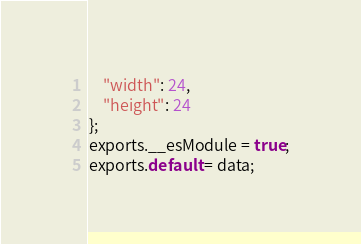Convert code to text. <code><loc_0><loc_0><loc_500><loc_500><_JavaScript_>	"width": 24,
	"height": 24
};
exports.__esModule = true;
exports.default = data;
</code> 